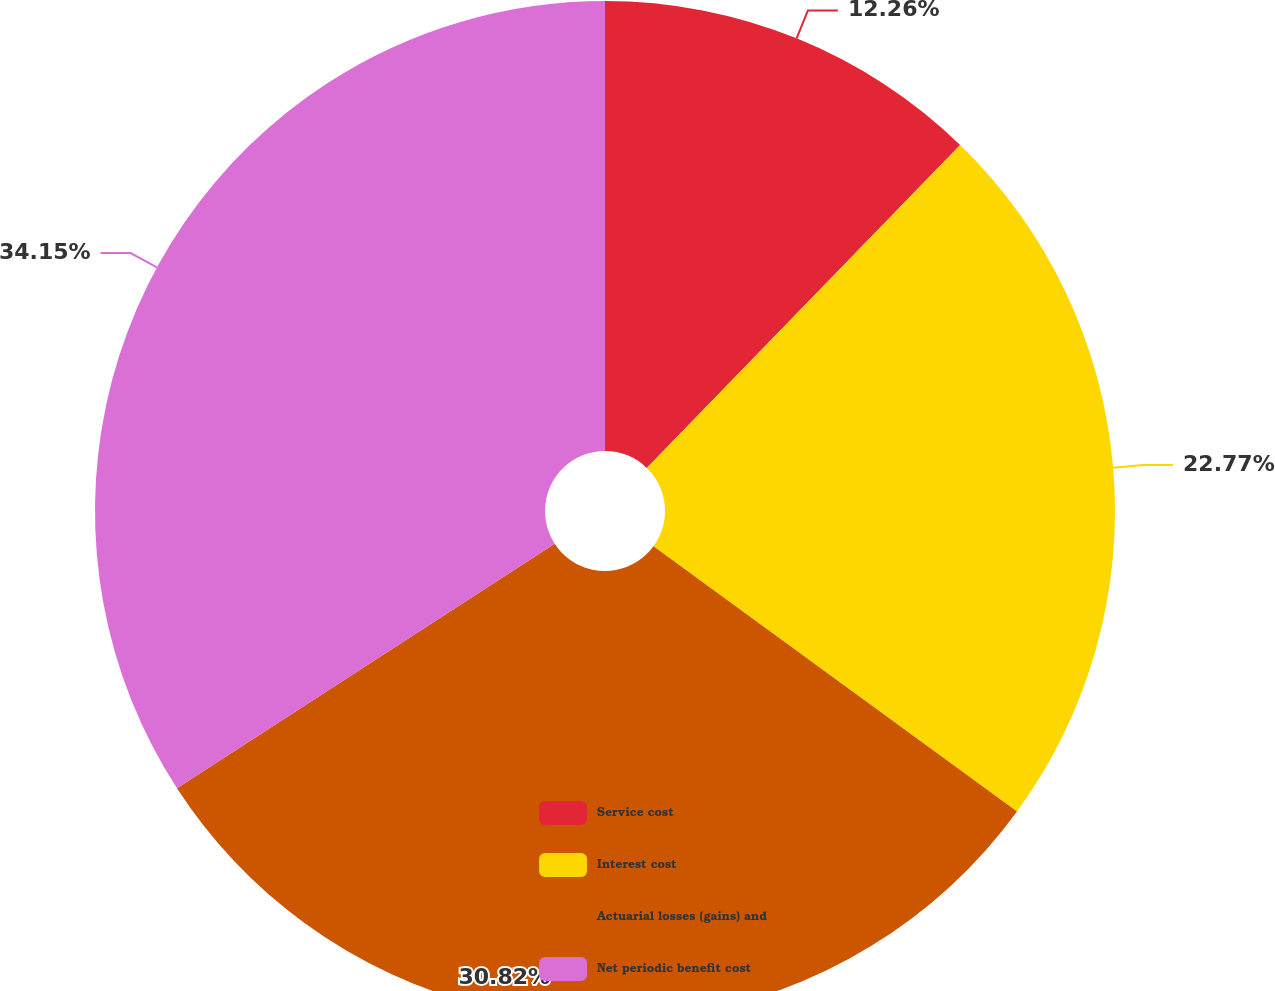Convert chart to OTSL. <chart><loc_0><loc_0><loc_500><loc_500><pie_chart><fcel>Service cost<fcel>Interest cost<fcel>Actuarial losses (gains) and<fcel>Net periodic benefit cost<nl><fcel>12.26%<fcel>22.77%<fcel>30.82%<fcel>34.15%<nl></chart> 